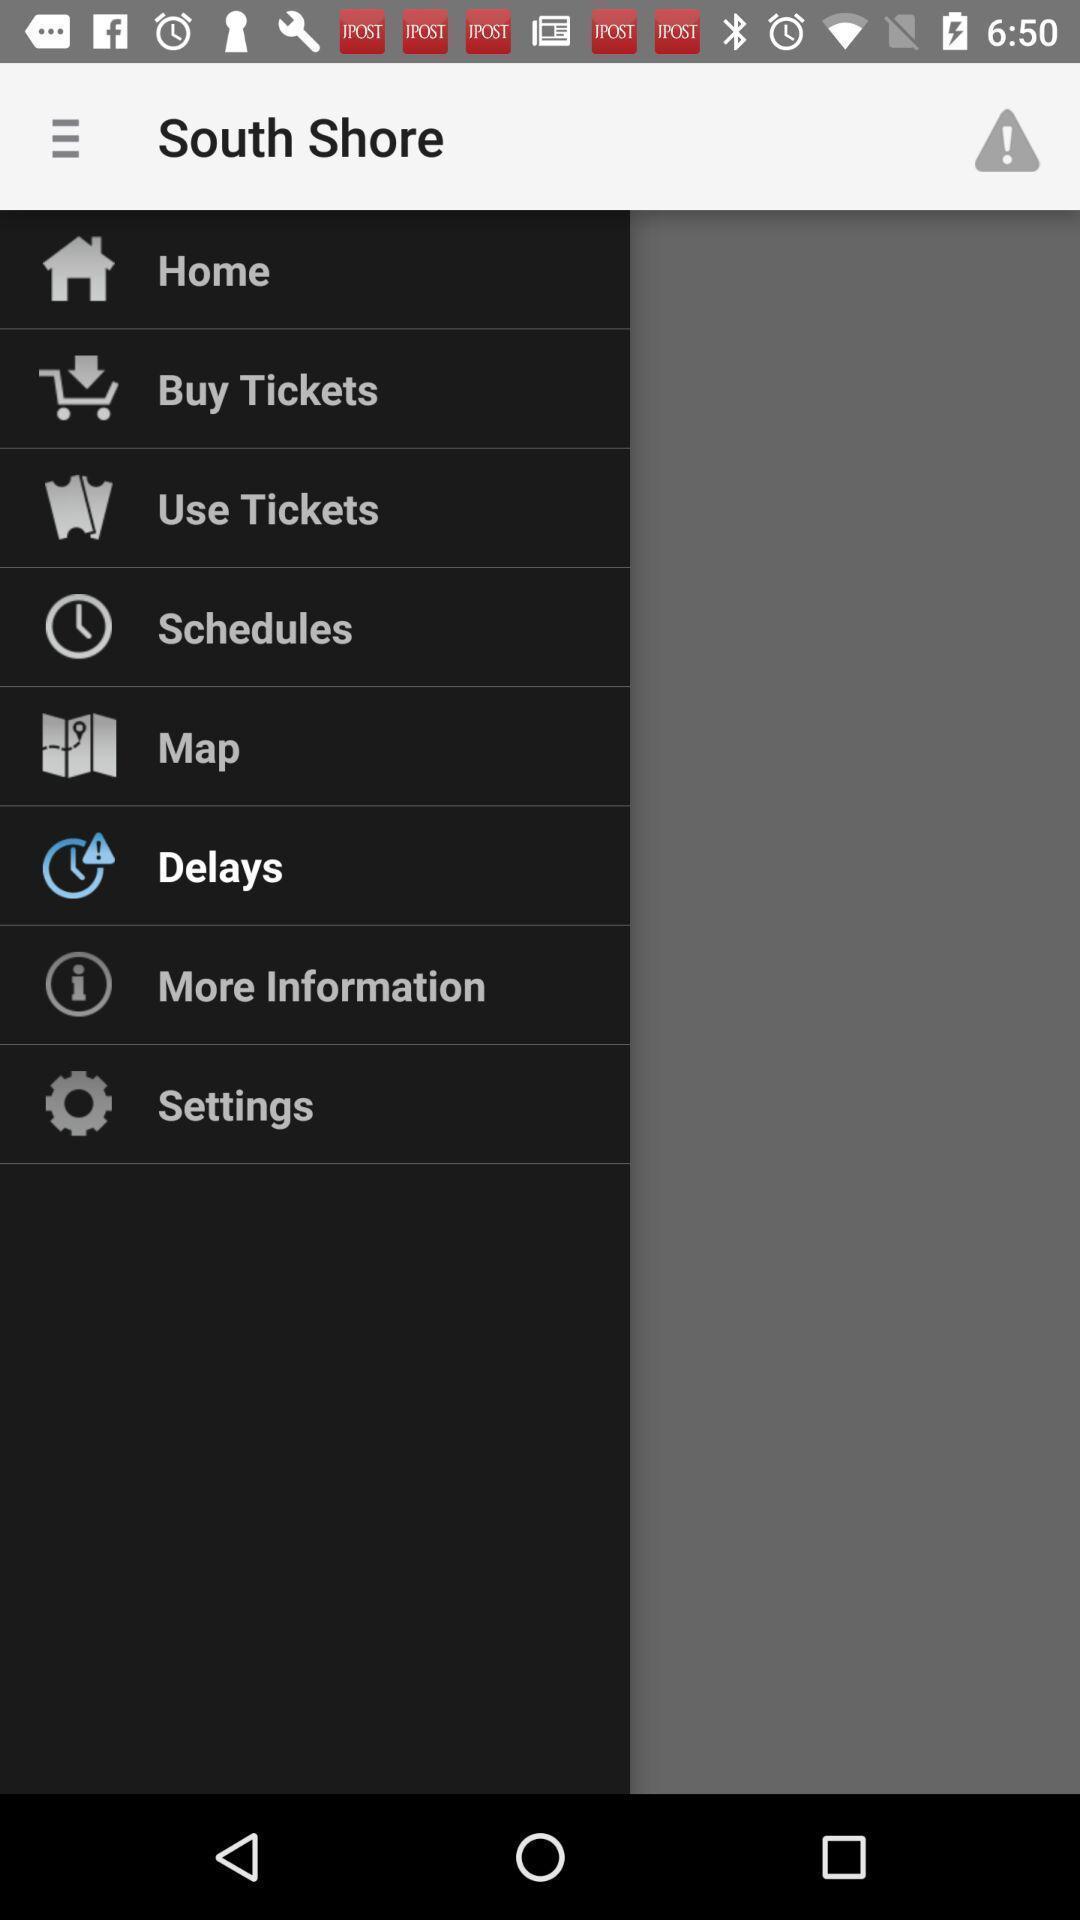Give me a narrative description of this picture. Screen displaying the menu. 